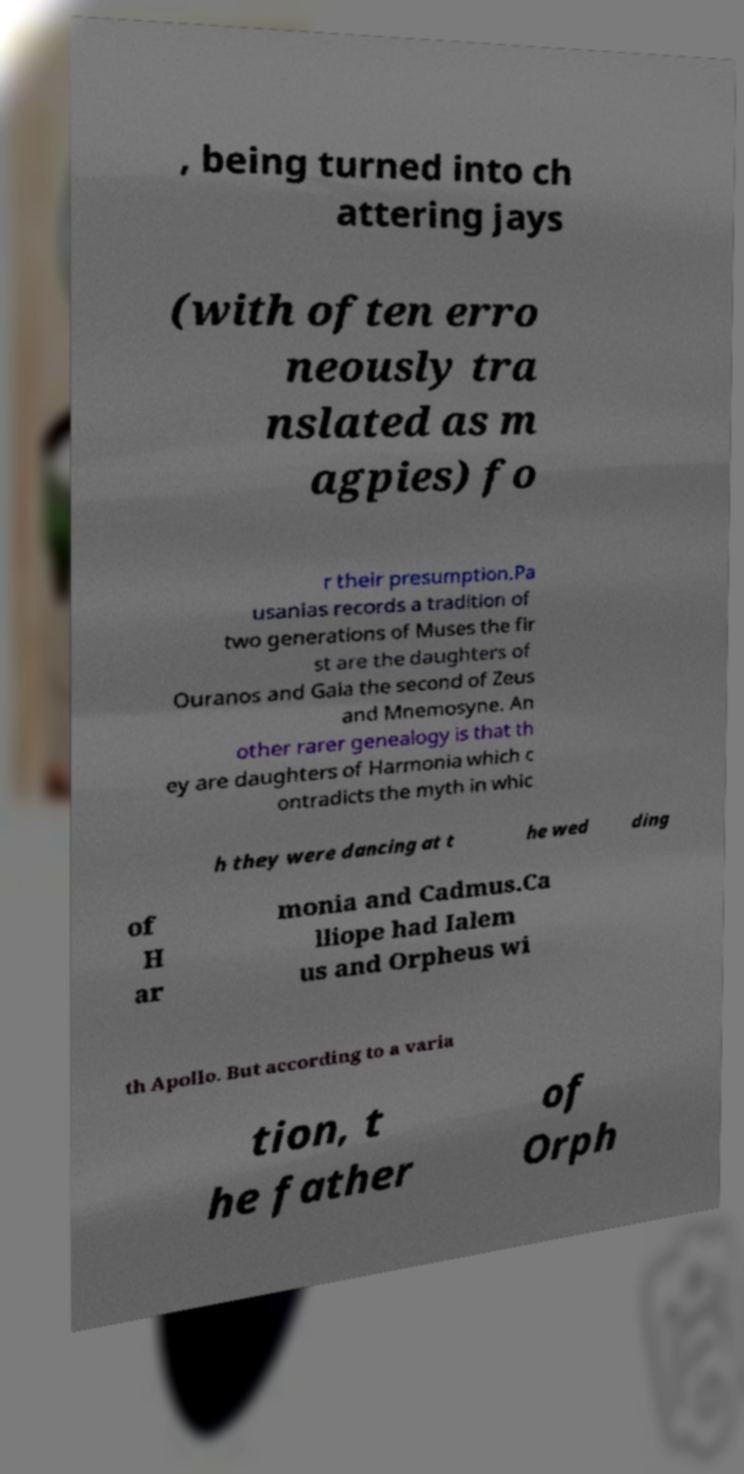Could you assist in decoding the text presented in this image and type it out clearly? , being turned into ch attering jays (with often erro neously tra nslated as m agpies) fo r their presumption.Pa usanias records a tradition of two generations of Muses the fir st are the daughters of Ouranos and Gaia the second of Zeus and Mnemosyne. An other rarer genealogy is that th ey are daughters of Harmonia which c ontradicts the myth in whic h they were dancing at t he wed ding of H ar monia and Cadmus.Ca lliope had Ialem us and Orpheus wi th Apollo. But according to a varia tion, t he father of Orph 